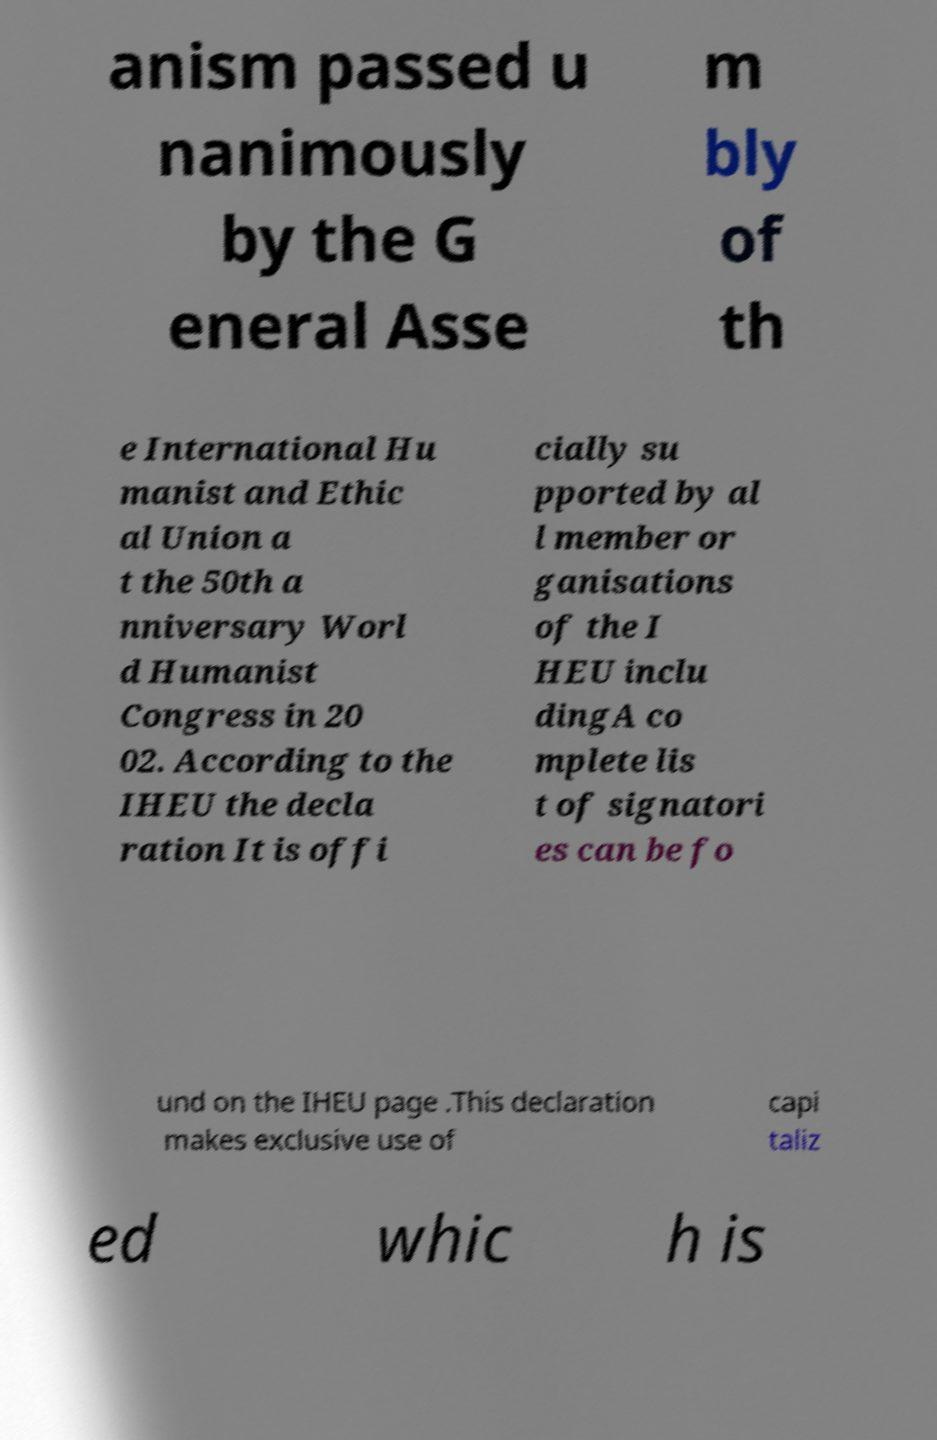Could you extract and type out the text from this image? anism passed u nanimously by the G eneral Asse m bly of th e International Hu manist and Ethic al Union a t the 50th a nniversary Worl d Humanist Congress in 20 02. According to the IHEU the decla ration It is offi cially su pported by al l member or ganisations of the I HEU inclu dingA co mplete lis t of signatori es can be fo und on the IHEU page .This declaration makes exclusive use of capi taliz ed whic h is 